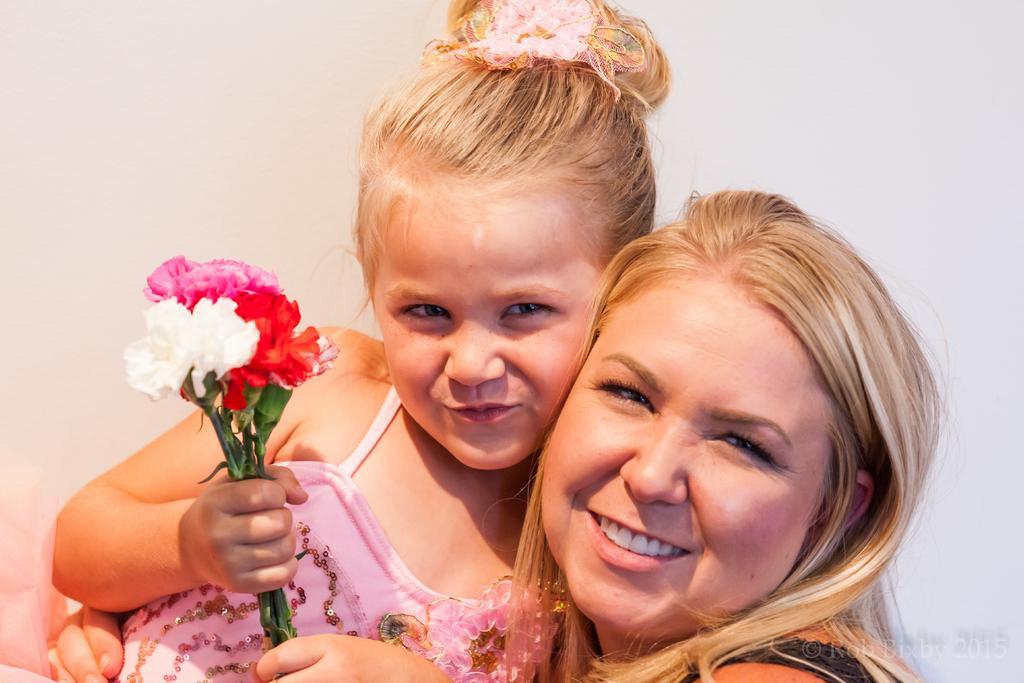Can you describe this image briefly? In this image there is a girl holding bunch of flowers and laying on another person , and there is a watermark on the image. 